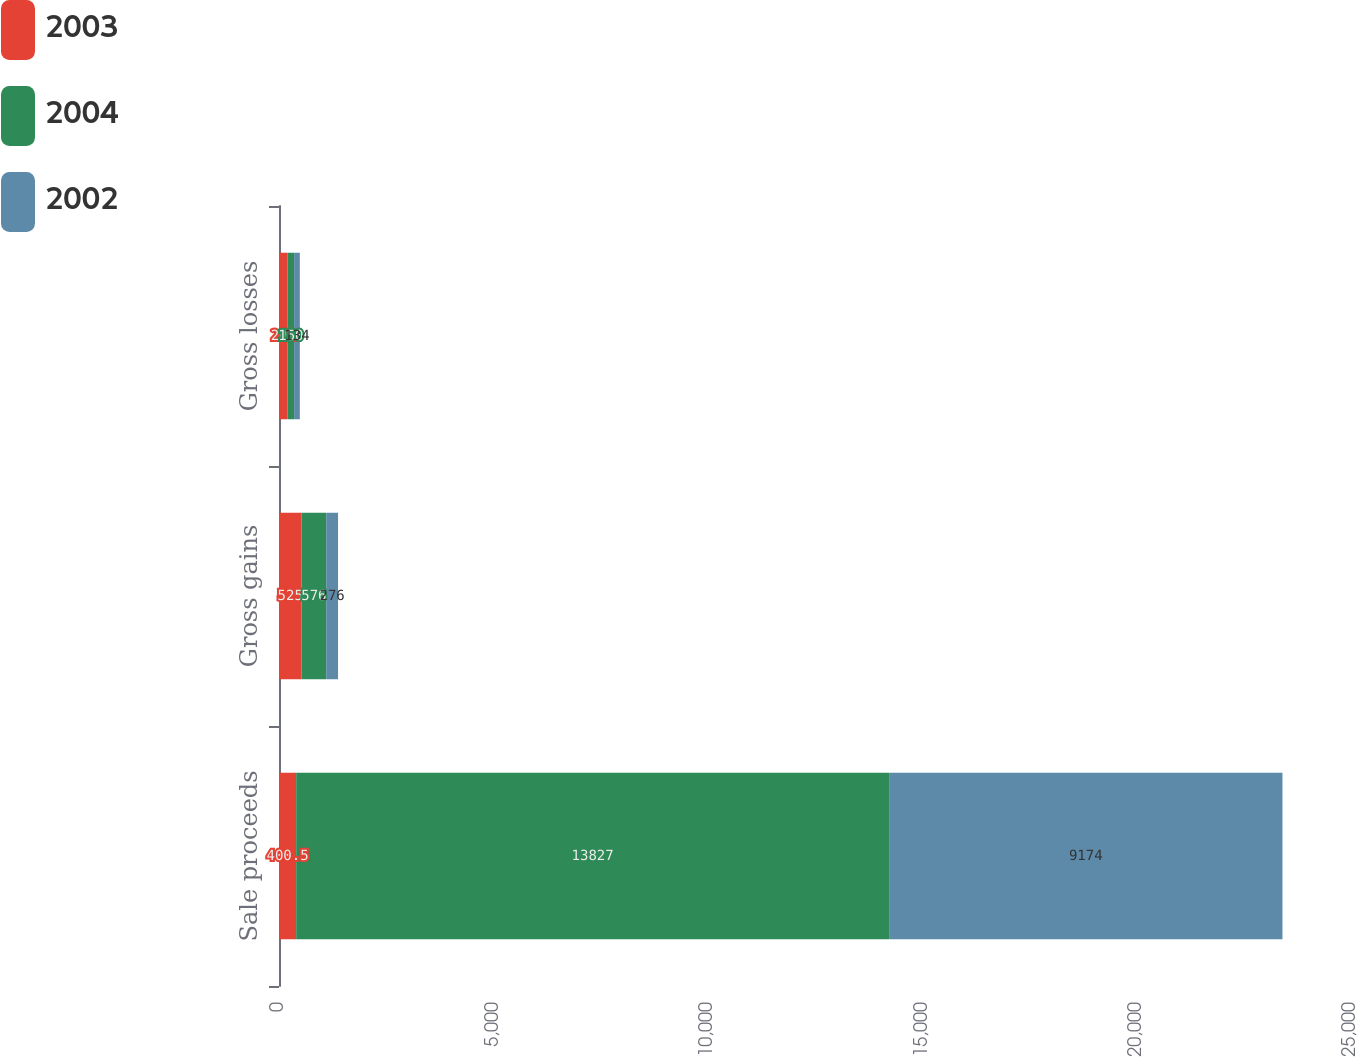<chart> <loc_0><loc_0><loc_500><loc_500><stacked_bar_chart><ecel><fcel>Sale proceeds<fcel>Gross gains<fcel>Gross losses<nl><fcel>2003<fcel>400.5<fcel>525<fcel>202<nl><fcel>2004<fcel>13827<fcel>576<fcel>150<nl><fcel>2002<fcel>9174<fcel>276<fcel>134<nl></chart> 